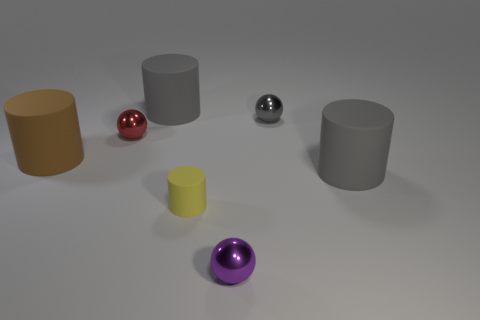Subtract all small matte cylinders. How many cylinders are left? 3 Subtract all red blocks. How many gray cylinders are left? 2 Add 2 large red cylinders. How many objects exist? 9 Subtract all gray cylinders. How many cylinders are left? 2 Subtract all balls. How many objects are left? 4 Add 5 big rubber objects. How many big rubber objects exist? 8 Subtract 0 green cubes. How many objects are left? 7 Subtract 1 cylinders. How many cylinders are left? 3 Subtract all brown cylinders. Subtract all red balls. How many cylinders are left? 3 Subtract all big rubber objects. Subtract all small metallic objects. How many objects are left? 1 